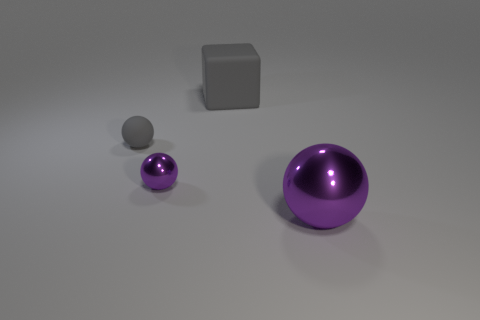Subtract all large purple metallic spheres. How many spheres are left? 2 Subtract 2 spheres. How many spheres are left? 1 Add 2 blue metallic blocks. How many objects exist? 6 Subtract all gray spheres. How many spheres are left? 2 Subtract all cyan cylinders. How many purple spheres are left? 2 Subtract 0 purple cylinders. How many objects are left? 4 Subtract all balls. How many objects are left? 1 Subtract all brown balls. Subtract all purple cylinders. How many balls are left? 3 Subtract all gray rubber balls. Subtract all brown matte blocks. How many objects are left? 3 Add 3 tiny objects. How many tiny objects are left? 5 